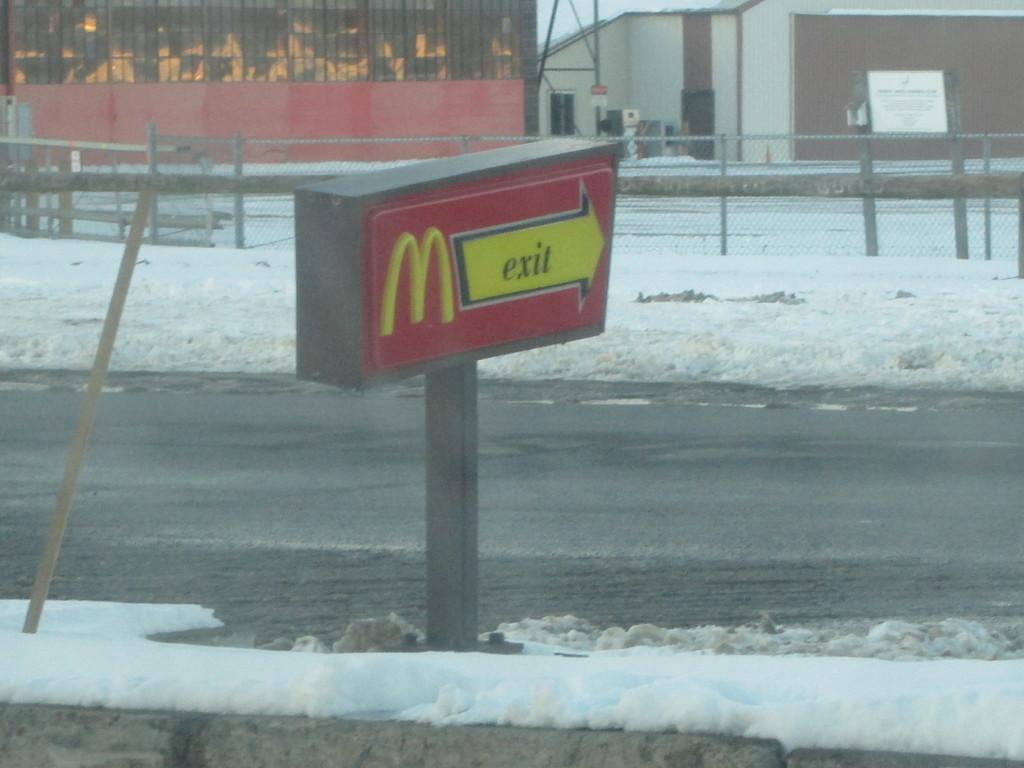How would you summarize this image in a sentence or two? In this image I see a board on this pole and I see something is written over here and I see the road and I see the white snow. In the background I see the fencing and I see few buildings. 